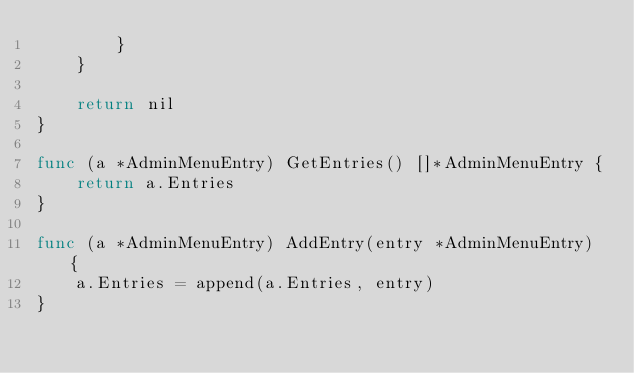<code> <loc_0><loc_0><loc_500><loc_500><_Go_>		}
	}

	return nil
}

func (a *AdminMenuEntry) GetEntries() []*AdminMenuEntry {
	return a.Entries
}

func (a *AdminMenuEntry) AddEntry(entry *AdminMenuEntry) {
	a.Entries = append(a.Entries, entry)
}
</code> 